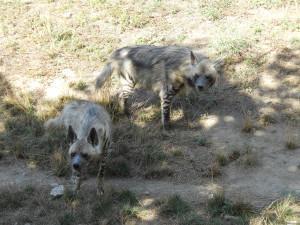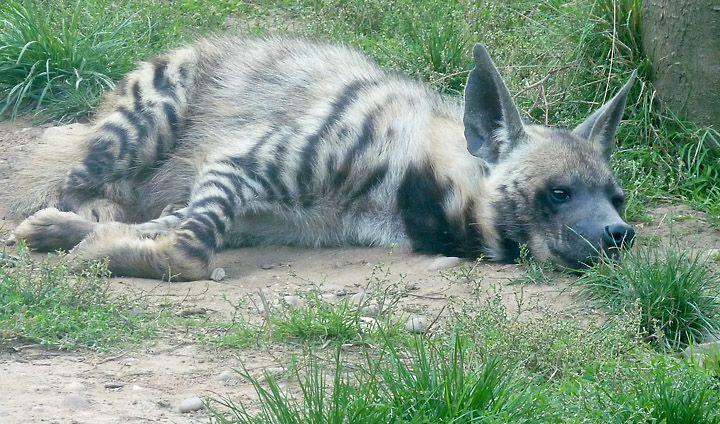The first image is the image on the left, the second image is the image on the right. For the images displayed, is the sentence "There are two animals in the image on the left." factually correct? Answer yes or no. Yes. 